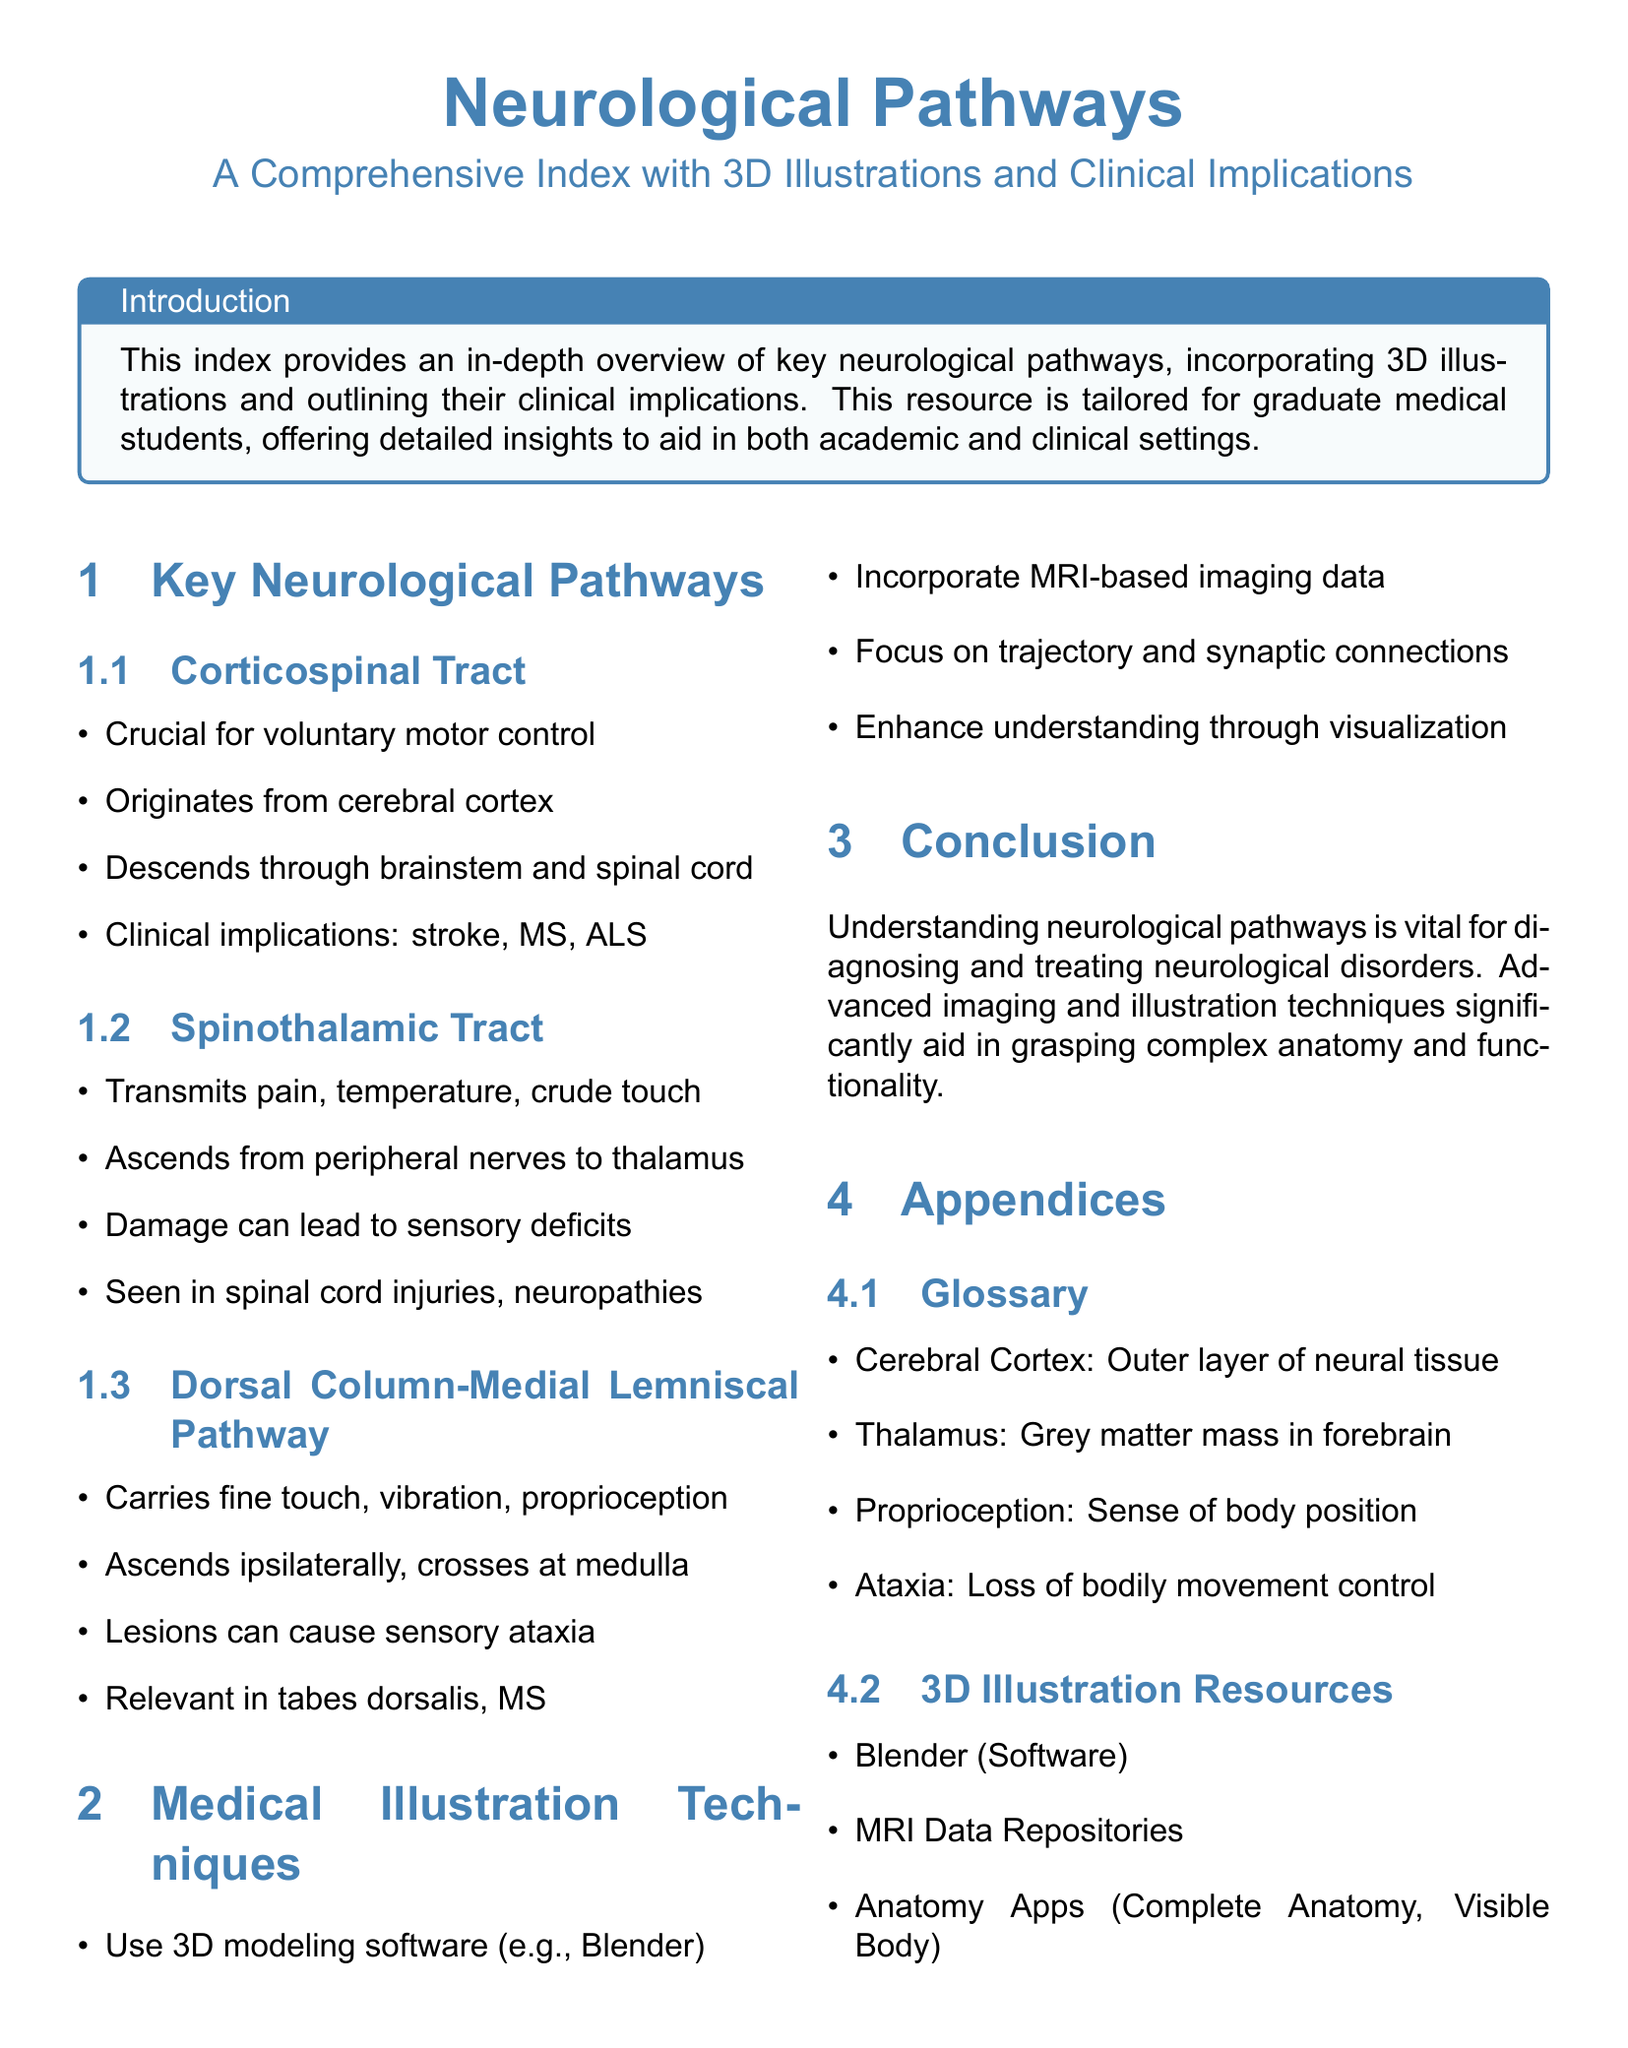What is the first neurological pathway listed? The first pathway mentioned in the index is the Corticospinal Tract.
Answer: Corticospinal Tract What does the Spinothalamic Tract transmit? The Spinothalamic Tract transmits pain, temperature, and crude touch.
Answer: Pain, temperature, crude touch Where does the Dorsal Column-Medial Lemniscal Pathway cross? This pathway crosses at the medulla.
Answer: Medulla What condition is associated with lesions in the Dorsal Column-Medial Lemniscal Pathway? Lesions in this pathway can cause sensory ataxia.
Answer: Sensory ataxia What medical illustration software is mentioned? The document mentions Blender as a software for medical illustration.
Answer: Blender How many key neurological pathways are listed? There are three key neurological pathways listed in the index.
Answer: Three What is defined as the outer layer of neural tissue? The outer layer of neural tissue is defined as the Cerebral Cortex.
Answer: Cerebral Cortex What does proprioception refer to? Proprioception refers to the sense of body position.
Answer: Sense of body position How does the Dorsal Column-Medial Lemniscal Pathway ascend? It ascends ipsilaterally to the brain.
Answer: Ipsilaterally 